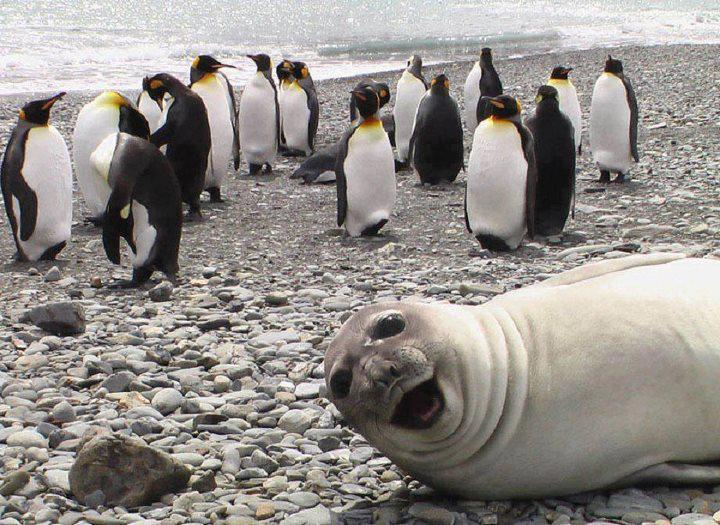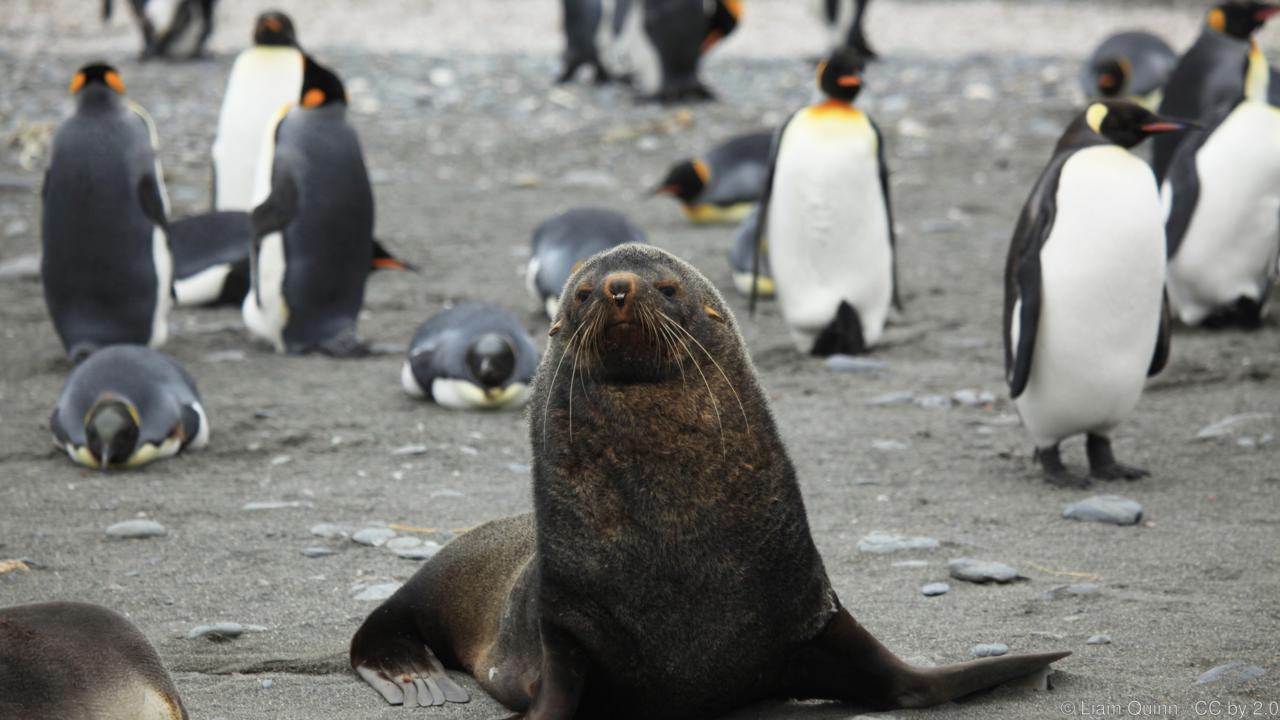The first image is the image on the left, the second image is the image on the right. Evaluate the accuracy of this statement regarding the images: "A seal photobombs in the lower right corner of one of the pictures.". Is it true? Answer yes or no. Yes. The first image is the image on the left, the second image is the image on the right. Considering the images on both sides, is "One of the images shows a penguin that is brown and fuzzy standing near a black and white penguin." valid? Answer yes or no. No. 